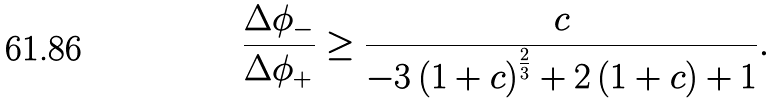<formula> <loc_0><loc_0><loc_500><loc_500>\frac { \Delta \phi _ { - } } { \Delta \phi _ { + } } \geq \frac { c } { { - 3 \left ( { 1 + c } \right ) ^ { \frac { 2 } { 3 } } + 2 \left ( { 1 + c } \right ) + 1 } } .</formula> 